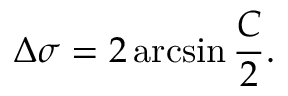Convert formula to latex. <formula><loc_0><loc_0><loc_500><loc_500>\Delta \sigma = 2 \arcsin { \frac { C } { 2 } } .</formula> 